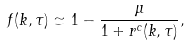Convert formula to latex. <formula><loc_0><loc_0><loc_500><loc_500>f ( k , \tau ) \simeq 1 - \frac { \mu } { 1 + r ^ { c } ( k , \tau ) } ,</formula> 